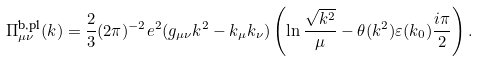<formula> <loc_0><loc_0><loc_500><loc_500>\Pi ^ { \text {b,pl} } _ { \mu \nu } ( k ) = \frac { 2 } { 3 } ( 2 \pi ) ^ { - 2 } e ^ { 2 } ( g _ { \mu \nu } k ^ { 2 } - k _ { \mu } k _ { \nu } ) \left ( \ln \frac { \sqrt { k ^ { 2 } } } { \mu } - \theta ( k ^ { 2 } ) \varepsilon ( k _ { 0 } ) \frac { i \pi } { 2 } \right ) .</formula> 